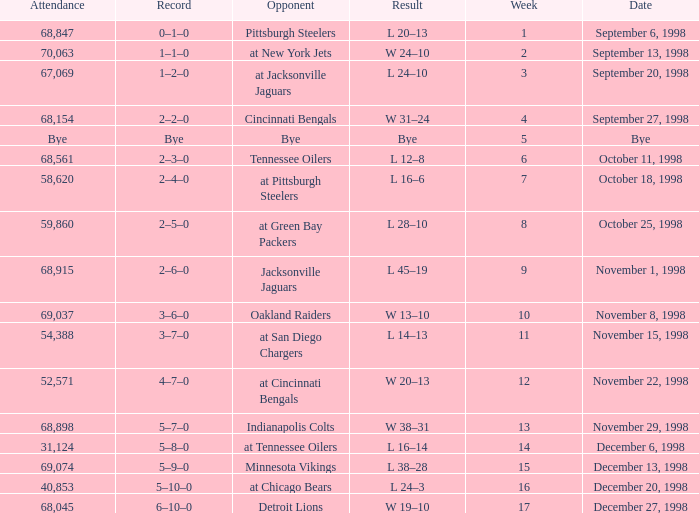What is the highest week that was played against the Minnesota Vikings? 15.0. 